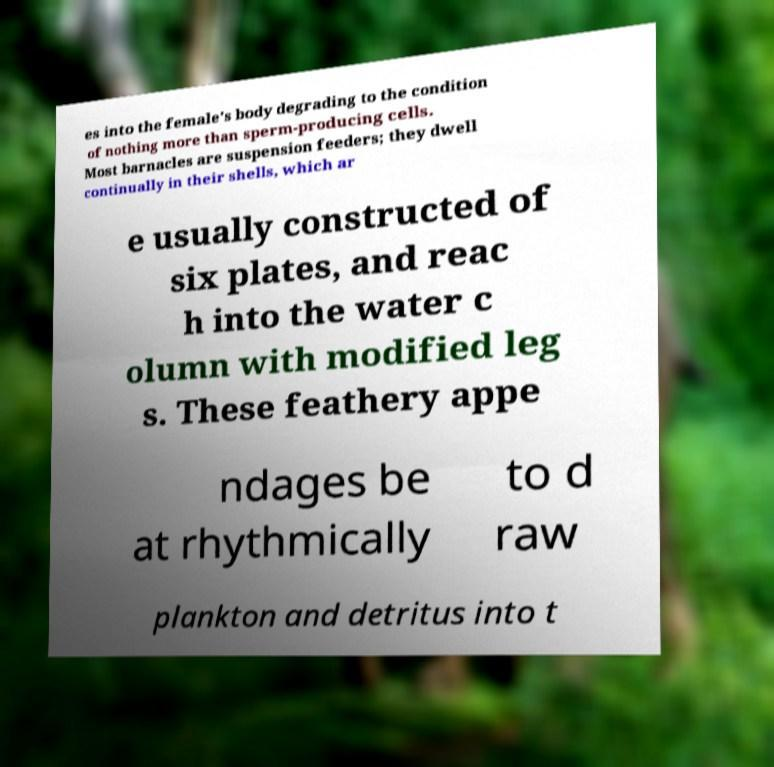There's text embedded in this image that I need extracted. Can you transcribe it verbatim? es into the female's body degrading to the condition of nothing more than sperm-producing cells. Most barnacles are suspension feeders; they dwell continually in their shells, which ar e usually constructed of six plates, and reac h into the water c olumn with modified leg s. These feathery appe ndages be at rhythmically to d raw plankton and detritus into t 